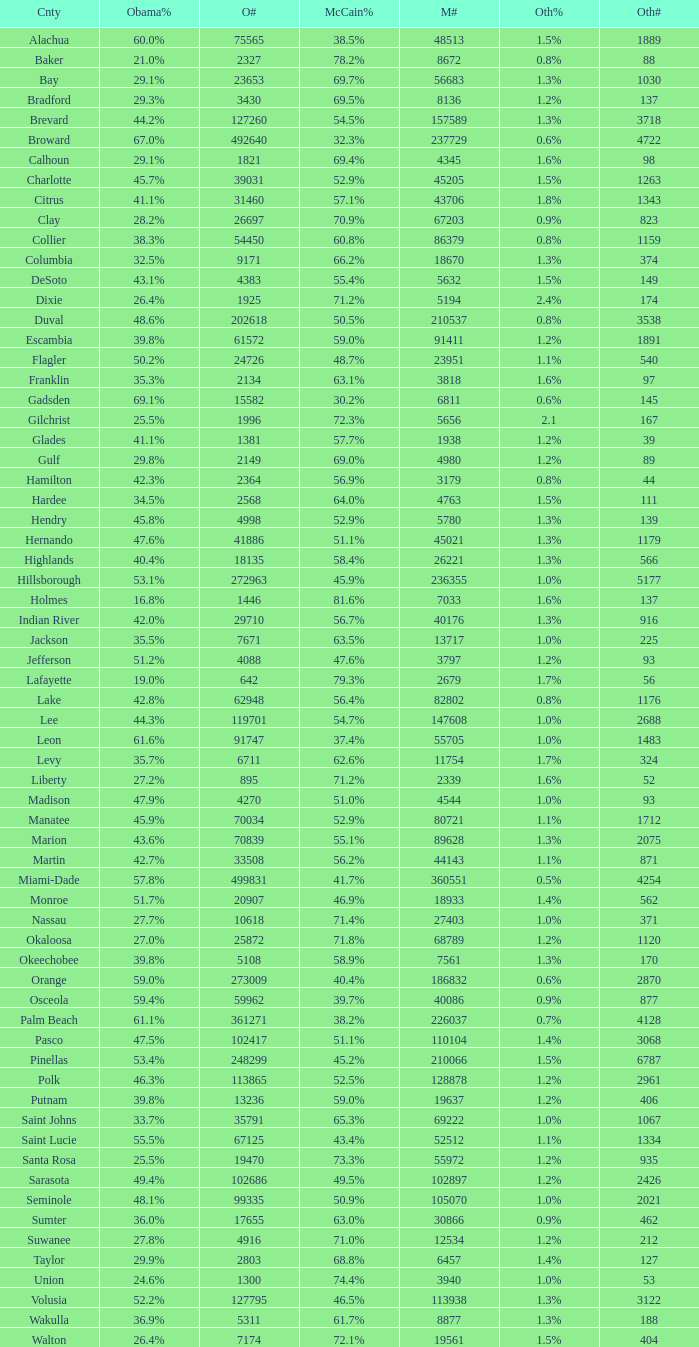What were the number of voters McCain had when Obama had 895? 2339.0. 